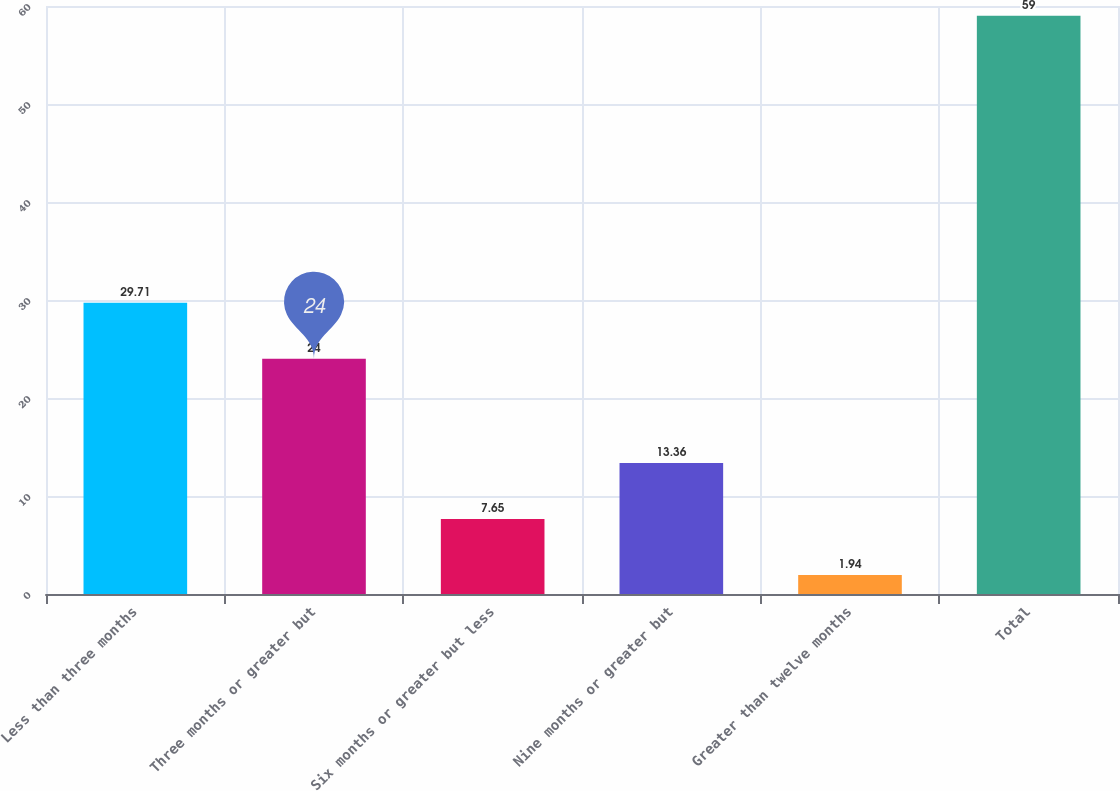Convert chart. <chart><loc_0><loc_0><loc_500><loc_500><bar_chart><fcel>Less than three months<fcel>Three months or greater but<fcel>Six months or greater but less<fcel>Nine months or greater but<fcel>Greater than twelve months<fcel>Total<nl><fcel>29.71<fcel>24<fcel>7.65<fcel>13.36<fcel>1.94<fcel>59<nl></chart> 